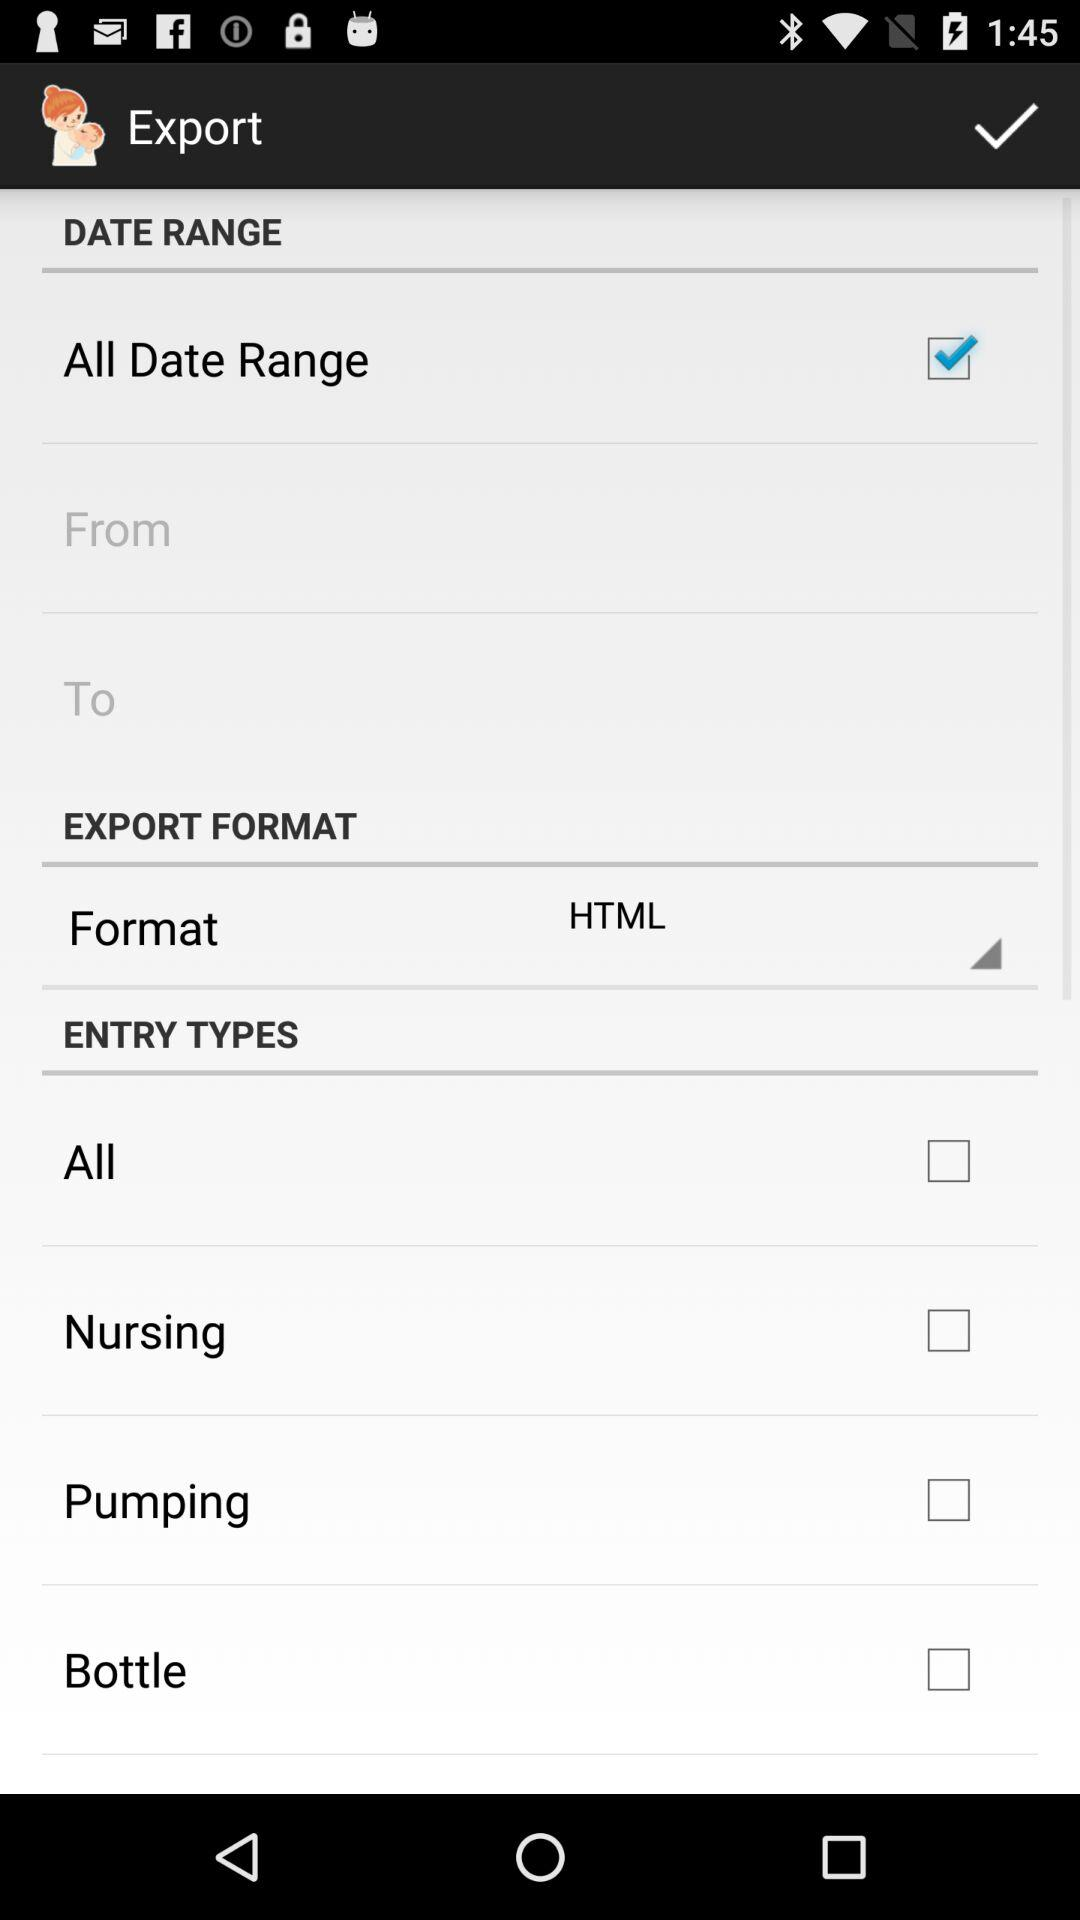How many checkboxes are there for entry types?
Answer the question using a single word or phrase. 4 